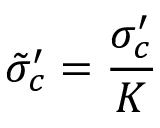<formula> <loc_0><loc_0><loc_500><loc_500>\tilde { \sigma } _ { c } ^ { \prime } = \frac { \sigma _ { c } ^ { \prime } } { K }</formula> 